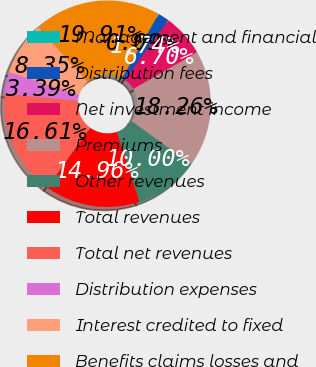<chart> <loc_0><loc_0><loc_500><loc_500><pie_chart><fcel>Management and financial<fcel>Distribution fees<fcel>Net investment income<fcel>Premiums<fcel>Other revenues<fcel>Total revenues<fcel>Total net revenues<fcel>Distribution expenses<fcel>Interest credited to fixed<fcel>Benefits claims losses and<nl><fcel>0.09%<fcel>1.74%<fcel>6.7%<fcel>18.26%<fcel>10.0%<fcel>14.96%<fcel>16.61%<fcel>3.39%<fcel>8.35%<fcel>19.91%<nl></chart> 